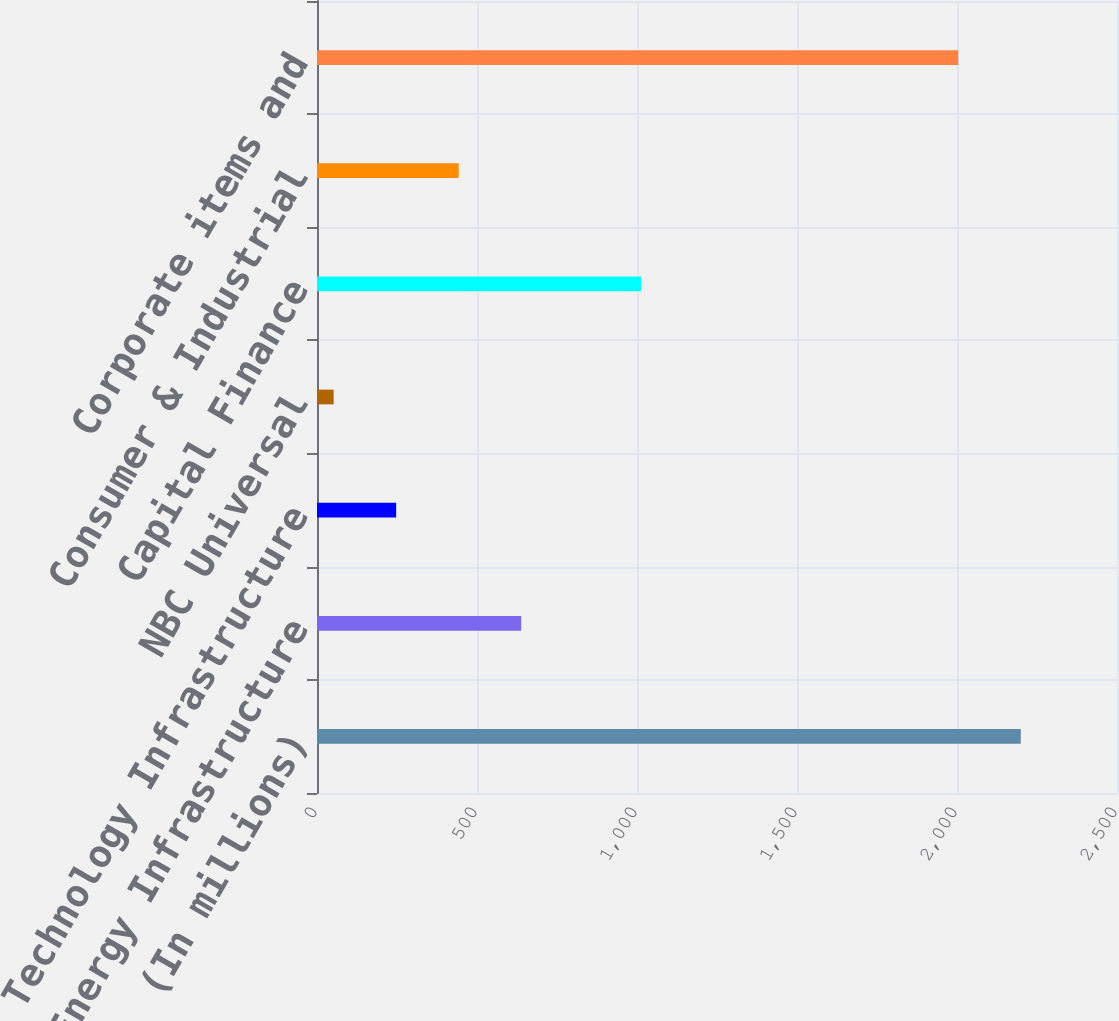Convert chart. <chart><loc_0><loc_0><loc_500><loc_500><bar_chart><fcel>(In millions)<fcel>Energy Infrastructure<fcel>Technology Infrastructure<fcel>NBC Universal<fcel>Capital Finance<fcel>Consumer & Industrial<fcel>Corporate items and<nl><fcel>2199.4<fcel>638.2<fcel>247.4<fcel>52<fcel>1013<fcel>442.8<fcel>2004<nl></chart> 